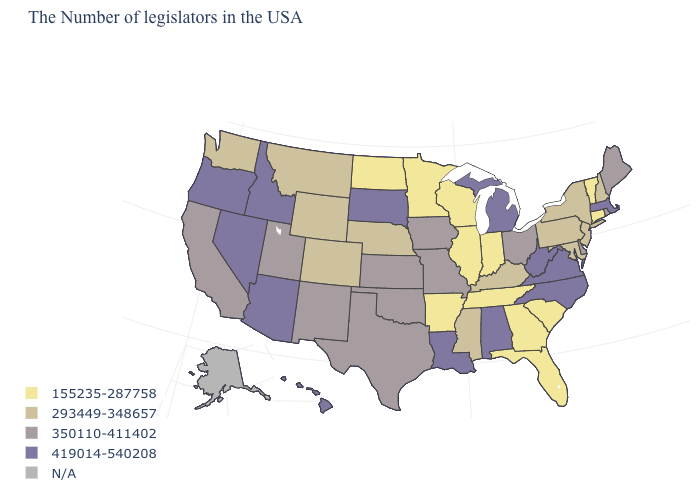Name the states that have a value in the range N/A?
Keep it brief. Alaska. What is the highest value in states that border Maryland?
Be succinct. 419014-540208. Does the map have missing data?
Give a very brief answer. Yes. How many symbols are there in the legend?
Short answer required. 5. Name the states that have a value in the range 155235-287758?
Write a very short answer. Vermont, Connecticut, South Carolina, Florida, Georgia, Indiana, Tennessee, Wisconsin, Illinois, Arkansas, Minnesota, North Dakota. How many symbols are there in the legend?
Give a very brief answer. 5. What is the highest value in states that border Colorado?
Short answer required. 419014-540208. Name the states that have a value in the range 350110-411402?
Short answer required. Maine, Rhode Island, Delaware, Ohio, Missouri, Iowa, Kansas, Oklahoma, Texas, New Mexico, Utah, California. What is the value of Texas?
Short answer required. 350110-411402. What is the lowest value in states that border New York?
Give a very brief answer. 155235-287758. Does Connecticut have the lowest value in the USA?
Short answer required. Yes. Does the map have missing data?
Write a very short answer. Yes. Does Iowa have the lowest value in the MidWest?
Give a very brief answer. No. Does New Mexico have the highest value in the USA?
Be succinct. No. Which states have the lowest value in the MidWest?
Give a very brief answer. Indiana, Wisconsin, Illinois, Minnesota, North Dakota. 